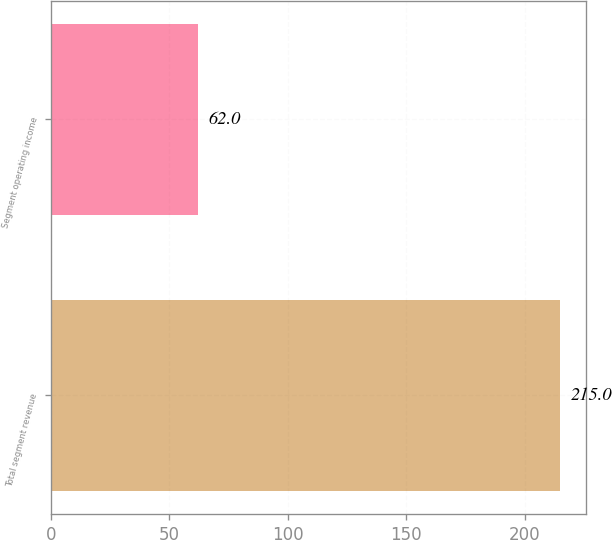<chart> <loc_0><loc_0><loc_500><loc_500><bar_chart><fcel>Total segment revenue<fcel>Segment operating income<nl><fcel>215<fcel>62<nl></chart> 